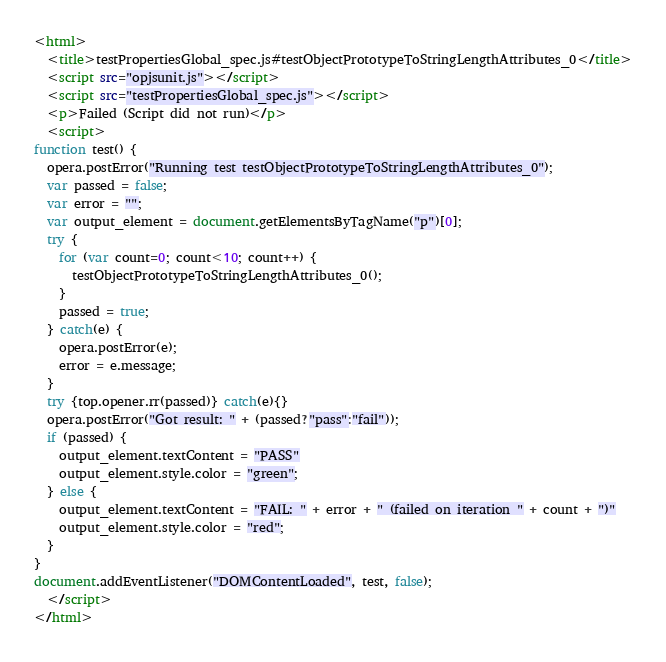<code> <loc_0><loc_0><loc_500><loc_500><_HTML_><html>
  <title>testPropertiesGlobal_spec.js#testObjectPrototypeToStringLengthAttributes_0</title>
  <script src="opjsunit.js"></script>
  <script src="testPropertiesGlobal_spec.js"></script>
  <p>Failed (Script did not run)</p>
  <script>
function test() {
  opera.postError("Running test testObjectPrototypeToStringLengthAttributes_0");
  var passed = false;
  var error = "";
  var output_element = document.getElementsByTagName("p")[0];
  try {
    for (var count=0; count<10; count++) {
      testObjectPrototypeToStringLengthAttributes_0();
    }
    passed = true;
  } catch(e) {
    opera.postError(e);
    error = e.message;
  }
  try {top.opener.rr(passed)} catch(e){}
  opera.postError("Got result: " + (passed?"pass":"fail"));
  if (passed) {
    output_element.textContent = "PASS"
    output_element.style.color = "green";
  } else {
    output_element.textContent = "FAIL: " + error + " (failed on iteration " + count + ")"
    output_element.style.color = "red";
  }
}
document.addEventListener("DOMContentLoaded", test, false);
  </script>
</html></code> 